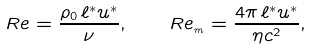Convert formula to latex. <formula><loc_0><loc_0><loc_500><loc_500>R e = \frac { \rho _ { 0 } \, \ell ^ { \ast } u ^ { \ast } } { \nu } , \quad R e _ { _ { m } } = \frac { 4 \pi \, \ell ^ { \ast } u ^ { \ast } } { \eta c ^ { 2 } } ,</formula> 